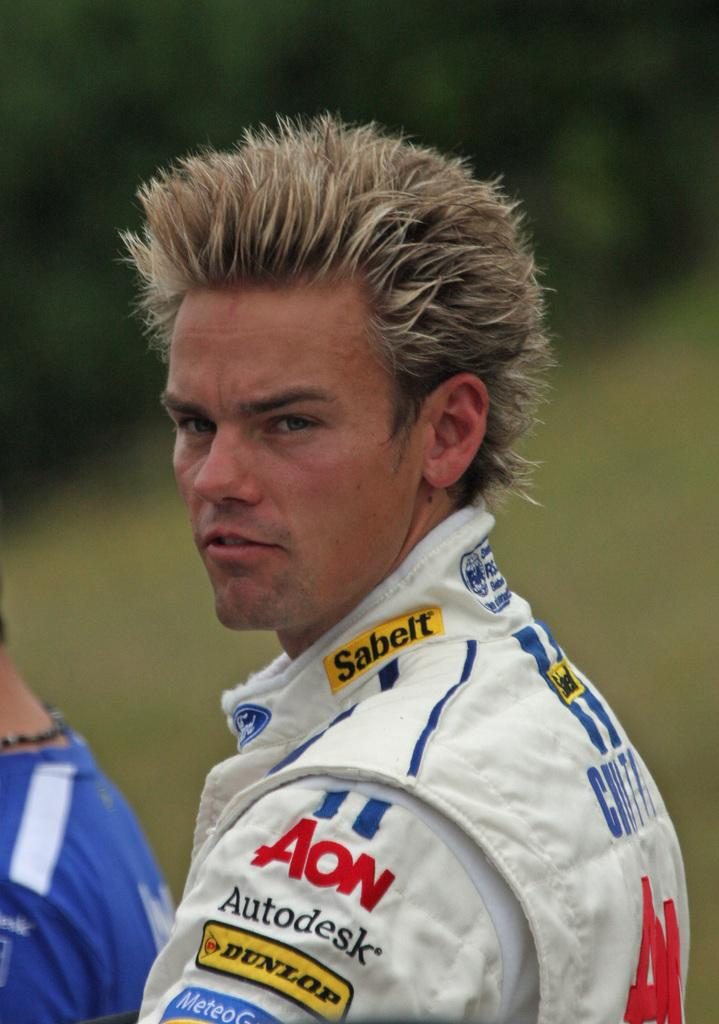<image>
Summarize the visual content of the image. The male shown has Autodesk and Dunlop advertised on his sleeve. 